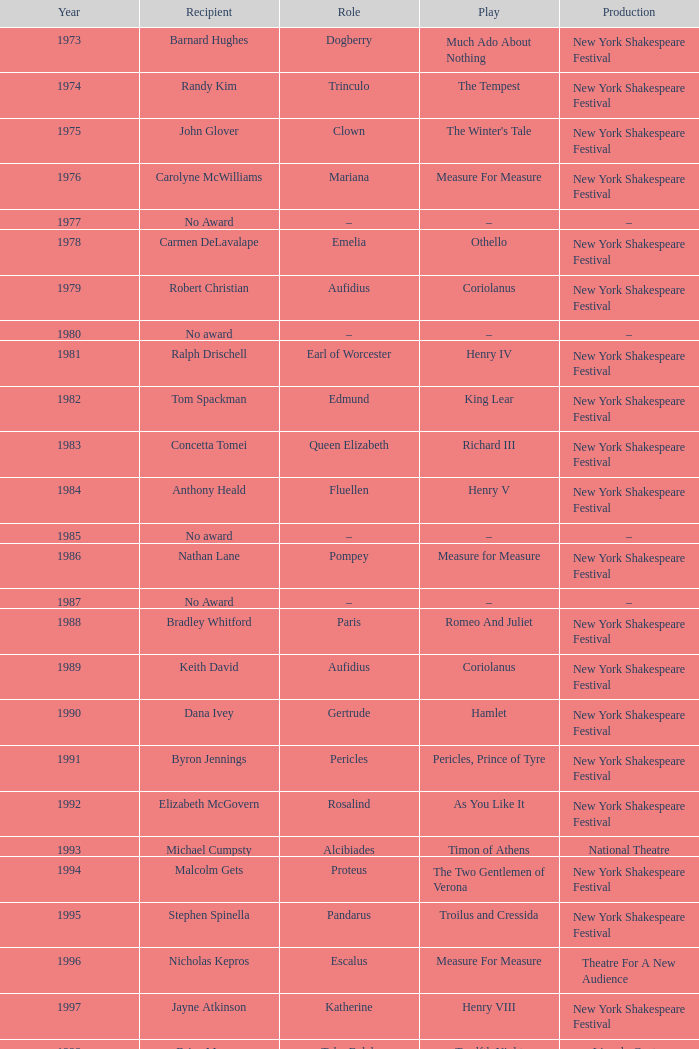Name the recipientof the year for 1976 Carolyne McWilliams. 